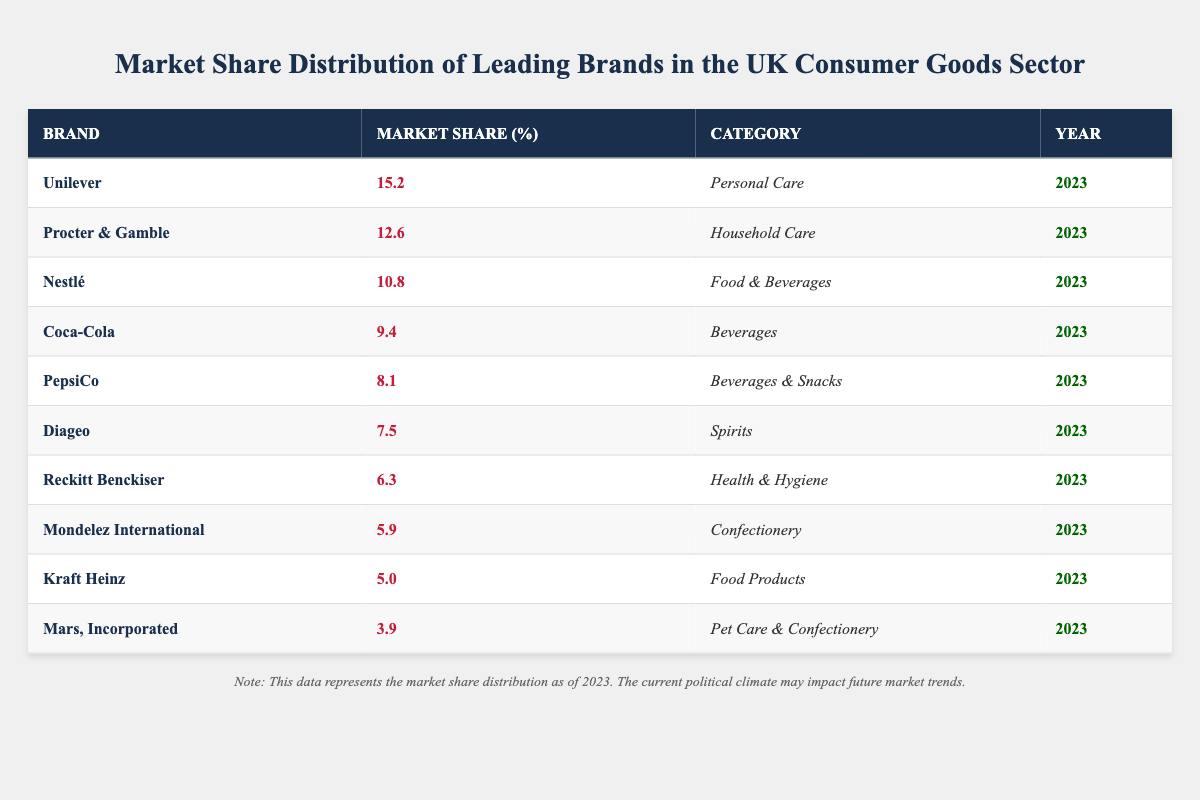What is the market share percentage of Unilever? According to the table, Unilever has a market share percentage of 15.2% for the year 2023.
Answer: 15.2% Which brand has the lowest market share in the UK Consumer Goods sector? The brand with the lowest market share in the table is Mars, Incorporated, with a market share percentage of 3.9% for the year 2023.
Answer: Mars, Incorporated What are the categories for Coca-Cola and PepsiCo? Coca-Cola falls under the category of Beverages, while PepsiCo is classified as Beverages & Snacks.
Answer: Beverages; Beverages & Snacks What is the combined market share percentage of Diageo and Reckitt Benckiser? Diageo has a market share percentage of 7.5% and Reckitt Benckiser has 6.3%. The combined market share is 7.5% + 6.3% = 13.8%.
Answer: 13.8% Is Nestlé's market share greater than Diageo's? The market share for Nestlé is 10.8%, which is greater than Diageo's 7.5%. Thus, the statement is true.
Answer: Yes What is the average market share of the top three brands? The top three brands are Unilever (15.2%), Procter & Gamble (12.6%), and Nestlé (10.8%). The total market share is 15.2% + 12.6% + 10.8% = 38.6%, and the average is 38.6% / 3 = 12.87%.
Answer: 12.87% Which brand's market share percentage is closest to the average market share of all listed brands? First, calculate the total market share: sum of all market shares = 15.2 + 12.6 + 10.8 + 9.4 + 8.1 + 7.5 + 6.3 + 5.9 + 5.0 + 3.9 = 79.7%. There are 10 brands, so the average is 79.7% / 10 = 7.97%. The closest market share percentage to this average is Reckitt Benckiser at 6.3%.
Answer: Reckitt Benckiser What percentage of the market share does the top two brands represent in total? The top two brands are Unilever (15.2%) and Procter & Gamble (12.6%). Their total market share is 15.2% + 12.6% = 27.8%.
Answer: 27.8% How many brands have a market share greater than 6%? By reviewing the table, the brands with a market share greater than 6% are Unilever, Procter & Gamble, Nestlé, Coca-Cola, PepsiCo, Diageo, and Reckitt Benckiser, totaling 7 brands.
Answer: 7 What percentage of the total market share is held by Mondelez International? Mondelez International has a market share percentage of 5.9%. To determine its percentage of the total, first calculate the overall market share (79.7%). Its share relative to the total market is (5.9 / 79.7) * 100% ≈ 7.40%.
Answer: 7.40% 